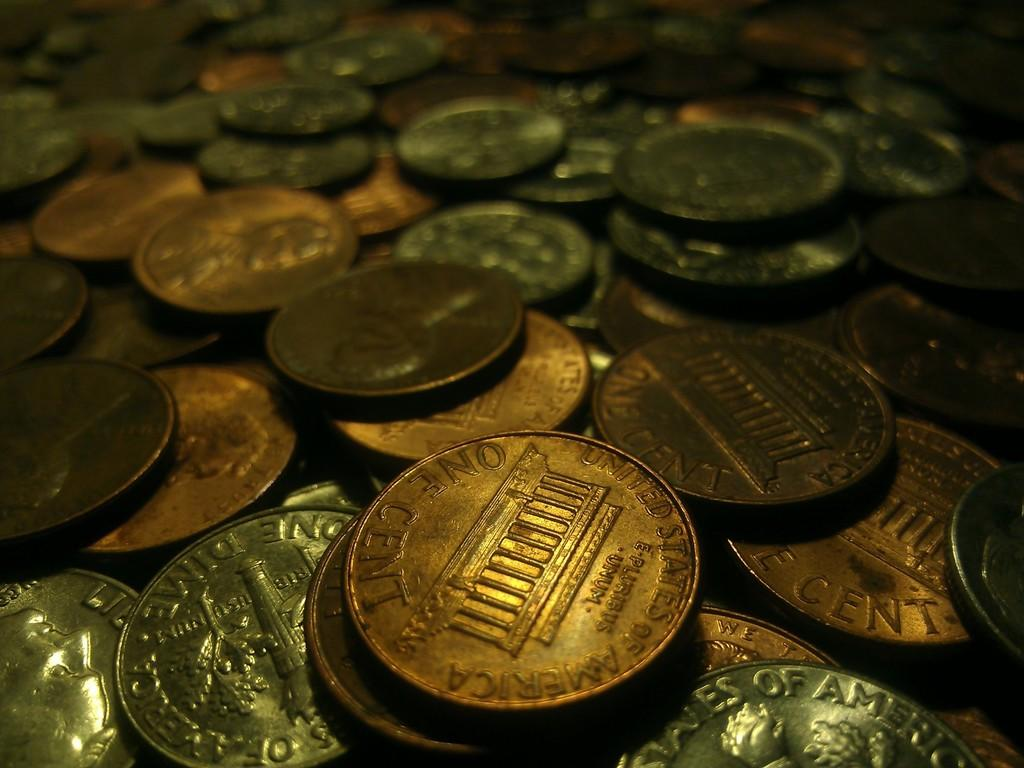<image>
Share a concise interpretation of the image provided. a pile of united state one cent pennies and dimes 